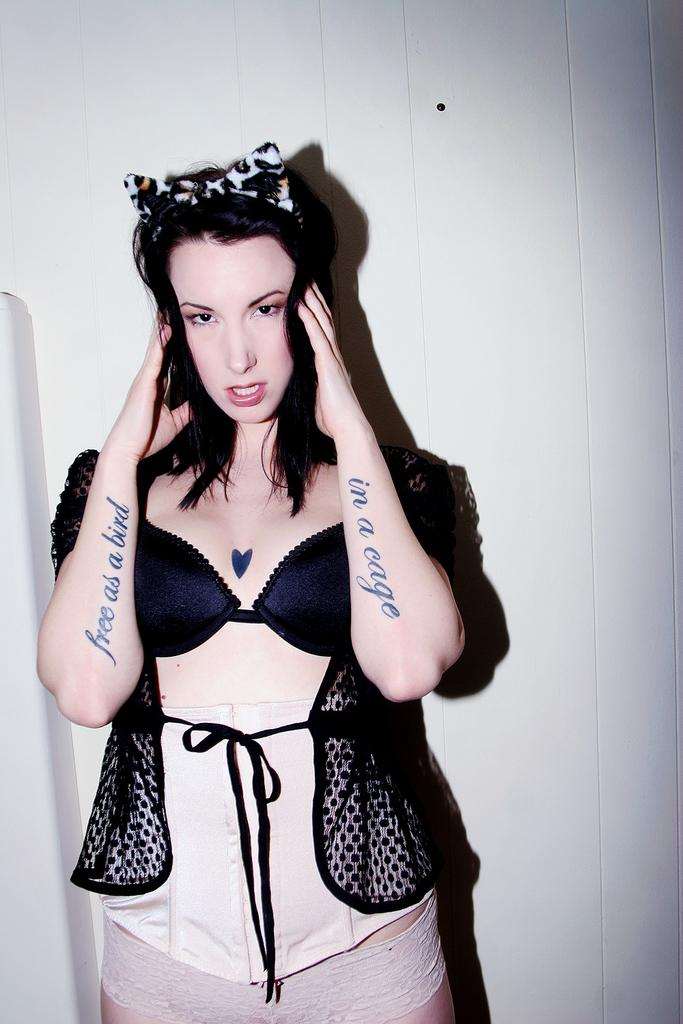What is the main subject of the image? There is a woman standing in the image. What can be seen in the background of the image? The background of the image is white. How does the woman's mind appear in the image? The woman's mind is not visible in the image, as it is an abstract concept and not something that can be seen. 